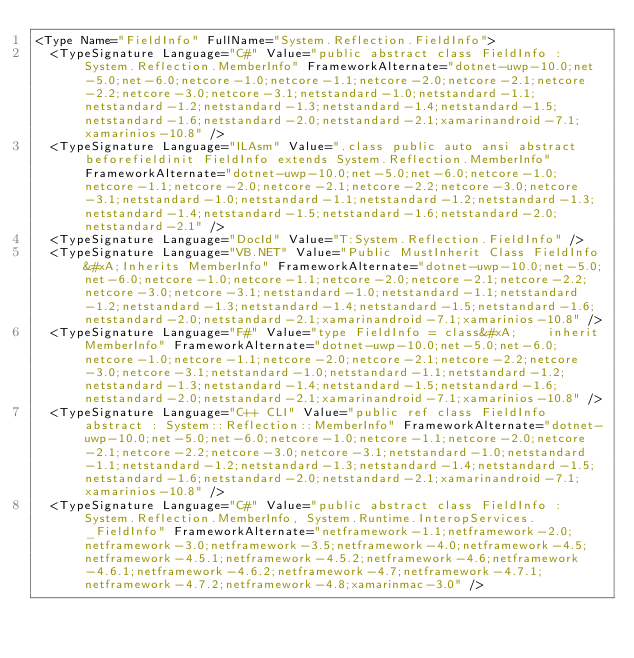<code> <loc_0><loc_0><loc_500><loc_500><_XML_><Type Name="FieldInfo" FullName="System.Reflection.FieldInfo">
  <TypeSignature Language="C#" Value="public abstract class FieldInfo : System.Reflection.MemberInfo" FrameworkAlternate="dotnet-uwp-10.0;net-5.0;net-6.0;netcore-1.0;netcore-1.1;netcore-2.0;netcore-2.1;netcore-2.2;netcore-3.0;netcore-3.1;netstandard-1.0;netstandard-1.1;netstandard-1.2;netstandard-1.3;netstandard-1.4;netstandard-1.5;netstandard-1.6;netstandard-2.0;netstandard-2.1;xamarinandroid-7.1;xamarinios-10.8" />
  <TypeSignature Language="ILAsm" Value=".class public auto ansi abstract beforefieldinit FieldInfo extends System.Reflection.MemberInfo" FrameworkAlternate="dotnet-uwp-10.0;net-5.0;net-6.0;netcore-1.0;netcore-1.1;netcore-2.0;netcore-2.1;netcore-2.2;netcore-3.0;netcore-3.1;netstandard-1.0;netstandard-1.1;netstandard-1.2;netstandard-1.3;netstandard-1.4;netstandard-1.5;netstandard-1.6;netstandard-2.0;netstandard-2.1" />
  <TypeSignature Language="DocId" Value="T:System.Reflection.FieldInfo" />
  <TypeSignature Language="VB.NET" Value="Public MustInherit Class FieldInfo&#xA;Inherits MemberInfo" FrameworkAlternate="dotnet-uwp-10.0;net-5.0;net-6.0;netcore-1.0;netcore-1.1;netcore-2.0;netcore-2.1;netcore-2.2;netcore-3.0;netcore-3.1;netstandard-1.0;netstandard-1.1;netstandard-1.2;netstandard-1.3;netstandard-1.4;netstandard-1.5;netstandard-1.6;netstandard-2.0;netstandard-2.1;xamarinandroid-7.1;xamarinios-10.8" />
  <TypeSignature Language="F#" Value="type FieldInfo = class&#xA;    inherit MemberInfo" FrameworkAlternate="dotnet-uwp-10.0;net-5.0;net-6.0;netcore-1.0;netcore-1.1;netcore-2.0;netcore-2.1;netcore-2.2;netcore-3.0;netcore-3.1;netstandard-1.0;netstandard-1.1;netstandard-1.2;netstandard-1.3;netstandard-1.4;netstandard-1.5;netstandard-1.6;netstandard-2.0;netstandard-2.1;xamarinandroid-7.1;xamarinios-10.8" />
  <TypeSignature Language="C++ CLI" Value="public ref class FieldInfo abstract : System::Reflection::MemberInfo" FrameworkAlternate="dotnet-uwp-10.0;net-5.0;net-6.0;netcore-1.0;netcore-1.1;netcore-2.0;netcore-2.1;netcore-2.2;netcore-3.0;netcore-3.1;netstandard-1.0;netstandard-1.1;netstandard-1.2;netstandard-1.3;netstandard-1.4;netstandard-1.5;netstandard-1.6;netstandard-2.0;netstandard-2.1;xamarinandroid-7.1;xamarinios-10.8" />
  <TypeSignature Language="C#" Value="public abstract class FieldInfo : System.Reflection.MemberInfo, System.Runtime.InteropServices._FieldInfo" FrameworkAlternate="netframework-1.1;netframework-2.0;netframework-3.0;netframework-3.5;netframework-4.0;netframework-4.5;netframework-4.5.1;netframework-4.5.2;netframework-4.6;netframework-4.6.1;netframework-4.6.2;netframework-4.7;netframework-4.7.1;netframework-4.7.2;netframework-4.8;xamarinmac-3.0" /></code> 